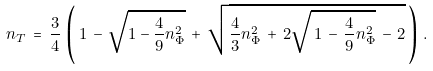Convert formula to latex. <formula><loc_0><loc_0><loc_500><loc_500>n _ { T } \, = \, \frac { 3 } { 4 } \, \left ( \, 1 \, - \, \sqrt { 1 - \frac { 4 } { 9 } n _ { \Phi } ^ { 2 } } \, + \, \sqrt { \frac { 4 } { 3 } n _ { \Phi } ^ { 2 } \, + \, 2 \sqrt { \, 1 \, - \, \frac { 4 } { 9 } n _ { \Phi } ^ { 2 } } \, - \, 2 } \, \right ) \, .</formula> 